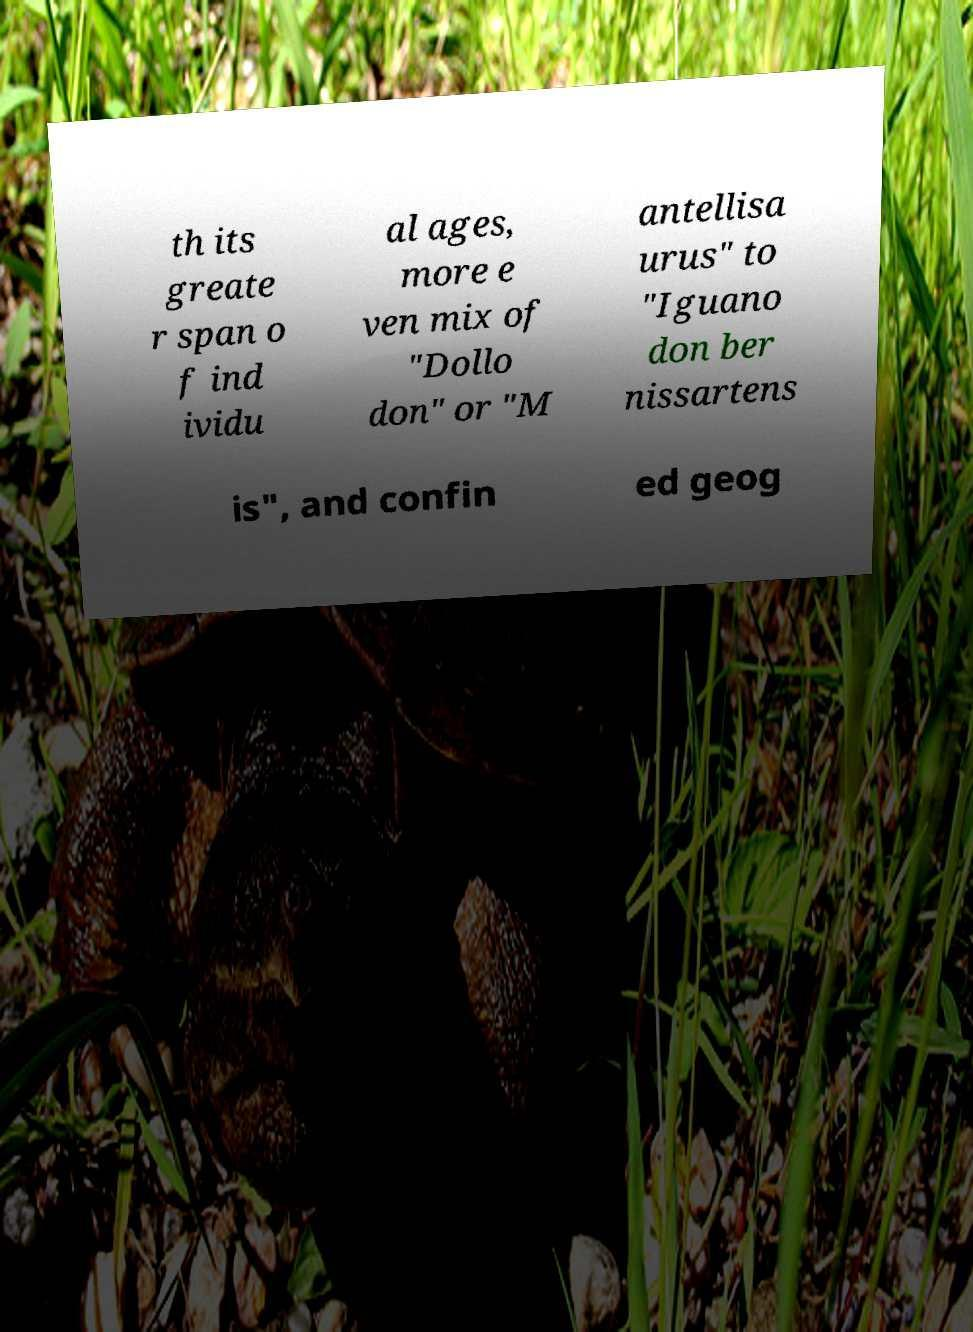Please identify and transcribe the text found in this image. th its greate r span o f ind ividu al ages, more e ven mix of "Dollo don" or "M antellisa urus" to "Iguano don ber nissartens is", and confin ed geog 